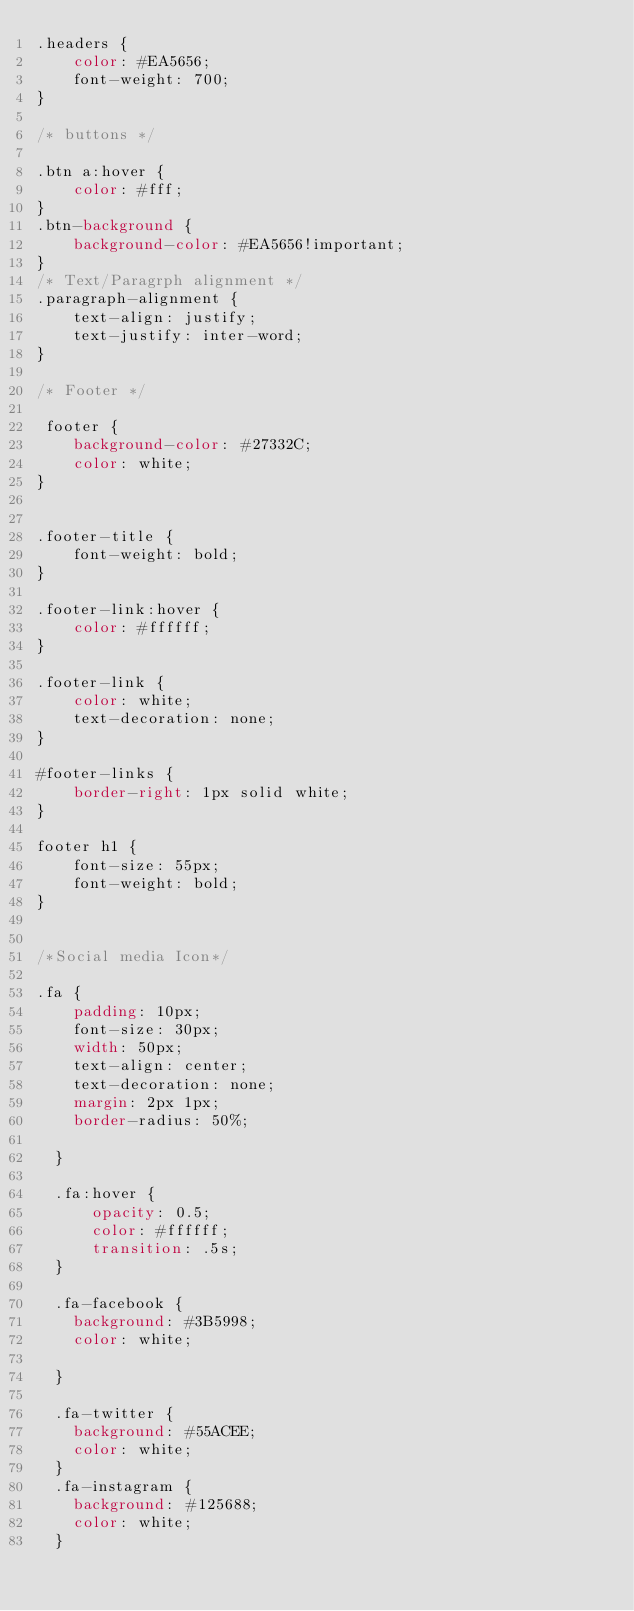Convert code to text. <code><loc_0><loc_0><loc_500><loc_500><_CSS_>.headers {
    color: #EA5656;
    font-weight: 700;
}

/* buttons */

.btn a:hover {
    color: #fff;
}
.btn-background {
    background-color: #EA5656!important;
}
/* Text/Paragrph alignment */
.paragraph-alignment {
    text-align: justify;
    text-justify: inter-word;
}

/* Footer */

 footer {
    background-color: #27332C;
    color: white;
}


.footer-title {
    font-weight: bold;
}

.footer-link:hover {
    color: #ffffff;
}

.footer-link {
    color: white;
    text-decoration: none;
}

#footer-links {
    border-right: 1px solid white;
}

footer h1 {
    font-size: 55px;
    font-weight: bold;
} 


/*Social media Icon*/

.fa {
    padding: 10px;
    font-size: 30px;
    width: 50px;
    text-align: center;
    text-decoration: none;
    margin: 2px 1px;
    border-radius: 50%;
    
  }
  
  .fa:hover {
      opacity: 0.5;
      color: #ffffff;
      transition: .5s;
  }
  
  .fa-facebook {
    background: #3B5998;
    color: white;
    
  }

  .fa-twitter {
    background: #55ACEE;
    color: white;
  }
  .fa-instagram {
    background: #125688;
    color: white;
  }</code> 